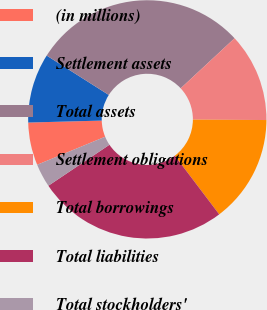Convert chart to OTSL. <chart><loc_0><loc_0><loc_500><loc_500><pie_chart><fcel>(in millions)<fcel>Settlement assets<fcel>Total assets<fcel>Settlement obligations<fcel>Total borrowings<fcel>Total liabilities<fcel>Total stockholders'<nl><fcel>5.8%<fcel>9.42%<fcel>29.09%<fcel>12.01%<fcel>14.6%<fcel>25.91%<fcel>3.18%<nl></chart> 